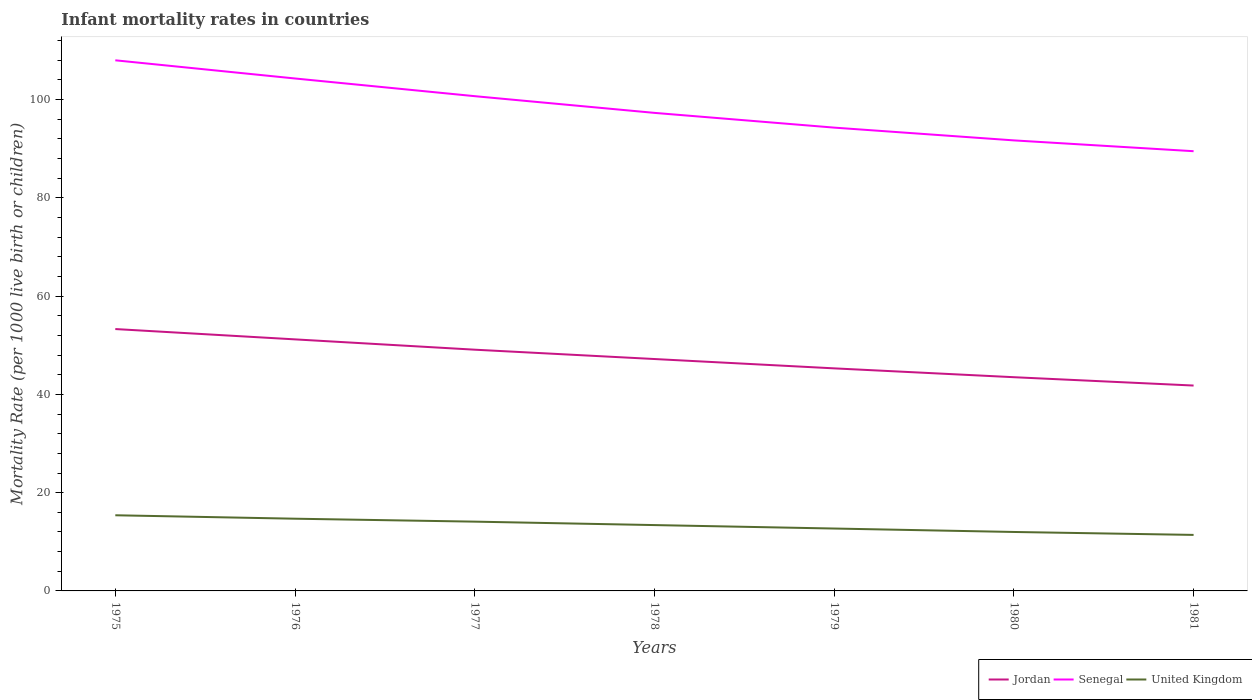Across all years, what is the maximum infant mortality rate in Jordan?
Make the answer very short. 41.8. In which year was the infant mortality rate in Senegal maximum?
Keep it short and to the point. 1981. What is the total infant mortality rate in Jordan in the graph?
Provide a short and direct response. 5.4. What is the difference between the highest and the second highest infant mortality rate in Senegal?
Your answer should be compact. 18.5. Is the infant mortality rate in Senegal strictly greater than the infant mortality rate in United Kingdom over the years?
Your answer should be compact. No. How many years are there in the graph?
Make the answer very short. 7. Are the values on the major ticks of Y-axis written in scientific E-notation?
Make the answer very short. No. Where does the legend appear in the graph?
Make the answer very short. Bottom right. What is the title of the graph?
Provide a short and direct response. Infant mortality rates in countries. What is the label or title of the X-axis?
Give a very brief answer. Years. What is the label or title of the Y-axis?
Make the answer very short. Mortality Rate (per 1000 live birth or children). What is the Mortality Rate (per 1000 live birth or children) in Jordan in 1975?
Offer a very short reply. 53.3. What is the Mortality Rate (per 1000 live birth or children) of Senegal in 1975?
Offer a very short reply. 108. What is the Mortality Rate (per 1000 live birth or children) in Jordan in 1976?
Your response must be concise. 51.2. What is the Mortality Rate (per 1000 live birth or children) of Senegal in 1976?
Make the answer very short. 104.3. What is the Mortality Rate (per 1000 live birth or children) of Jordan in 1977?
Your answer should be compact. 49.1. What is the Mortality Rate (per 1000 live birth or children) in Senegal in 1977?
Provide a short and direct response. 100.7. What is the Mortality Rate (per 1000 live birth or children) in United Kingdom in 1977?
Provide a succinct answer. 14.1. What is the Mortality Rate (per 1000 live birth or children) in Jordan in 1978?
Your response must be concise. 47.2. What is the Mortality Rate (per 1000 live birth or children) in Senegal in 1978?
Give a very brief answer. 97.3. What is the Mortality Rate (per 1000 live birth or children) in United Kingdom in 1978?
Your answer should be compact. 13.4. What is the Mortality Rate (per 1000 live birth or children) in Jordan in 1979?
Keep it short and to the point. 45.3. What is the Mortality Rate (per 1000 live birth or children) in Senegal in 1979?
Your response must be concise. 94.3. What is the Mortality Rate (per 1000 live birth or children) of United Kingdom in 1979?
Provide a short and direct response. 12.7. What is the Mortality Rate (per 1000 live birth or children) of Jordan in 1980?
Offer a terse response. 43.5. What is the Mortality Rate (per 1000 live birth or children) in Senegal in 1980?
Give a very brief answer. 91.7. What is the Mortality Rate (per 1000 live birth or children) in United Kingdom in 1980?
Your response must be concise. 12. What is the Mortality Rate (per 1000 live birth or children) in Jordan in 1981?
Your response must be concise. 41.8. What is the Mortality Rate (per 1000 live birth or children) of Senegal in 1981?
Provide a short and direct response. 89.5. Across all years, what is the maximum Mortality Rate (per 1000 live birth or children) of Jordan?
Give a very brief answer. 53.3. Across all years, what is the maximum Mortality Rate (per 1000 live birth or children) of Senegal?
Keep it short and to the point. 108. Across all years, what is the maximum Mortality Rate (per 1000 live birth or children) in United Kingdom?
Your response must be concise. 15.4. Across all years, what is the minimum Mortality Rate (per 1000 live birth or children) of Jordan?
Your answer should be compact. 41.8. Across all years, what is the minimum Mortality Rate (per 1000 live birth or children) of Senegal?
Offer a very short reply. 89.5. Across all years, what is the minimum Mortality Rate (per 1000 live birth or children) in United Kingdom?
Provide a succinct answer. 11.4. What is the total Mortality Rate (per 1000 live birth or children) in Jordan in the graph?
Ensure brevity in your answer.  331.4. What is the total Mortality Rate (per 1000 live birth or children) of Senegal in the graph?
Make the answer very short. 685.8. What is the total Mortality Rate (per 1000 live birth or children) of United Kingdom in the graph?
Give a very brief answer. 93.7. What is the difference between the Mortality Rate (per 1000 live birth or children) of Jordan in 1975 and that in 1976?
Give a very brief answer. 2.1. What is the difference between the Mortality Rate (per 1000 live birth or children) of United Kingdom in 1975 and that in 1978?
Keep it short and to the point. 2. What is the difference between the Mortality Rate (per 1000 live birth or children) of Jordan in 1975 and that in 1979?
Offer a terse response. 8. What is the difference between the Mortality Rate (per 1000 live birth or children) of Jordan in 1975 and that in 1980?
Your response must be concise. 9.8. What is the difference between the Mortality Rate (per 1000 live birth or children) in Jordan in 1975 and that in 1981?
Your answer should be compact. 11.5. What is the difference between the Mortality Rate (per 1000 live birth or children) in United Kingdom in 1975 and that in 1981?
Give a very brief answer. 4. What is the difference between the Mortality Rate (per 1000 live birth or children) of Jordan in 1976 and that in 1977?
Your response must be concise. 2.1. What is the difference between the Mortality Rate (per 1000 live birth or children) in Senegal in 1976 and that in 1977?
Keep it short and to the point. 3.6. What is the difference between the Mortality Rate (per 1000 live birth or children) of Jordan in 1976 and that in 1978?
Your answer should be compact. 4. What is the difference between the Mortality Rate (per 1000 live birth or children) in Senegal in 1976 and that in 1978?
Keep it short and to the point. 7. What is the difference between the Mortality Rate (per 1000 live birth or children) in United Kingdom in 1976 and that in 1978?
Provide a succinct answer. 1.3. What is the difference between the Mortality Rate (per 1000 live birth or children) in Jordan in 1976 and that in 1979?
Offer a terse response. 5.9. What is the difference between the Mortality Rate (per 1000 live birth or children) in Senegal in 1976 and that in 1979?
Your response must be concise. 10. What is the difference between the Mortality Rate (per 1000 live birth or children) of Jordan in 1976 and that in 1981?
Your answer should be compact. 9.4. What is the difference between the Mortality Rate (per 1000 live birth or children) of Senegal in 1976 and that in 1981?
Your response must be concise. 14.8. What is the difference between the Mortality Rate (per 1000 live birth or children) in Jordan in 1977 and that in 1979?
Your response must be concise. 3.8. What is the difference between the Mortality Rate (per 1000 live birth or children) in Senegal in 1977 and that in 1979?
Provide a short and direct response. 6.4. What is the difference between the Mortality Rate (per 1000 live birth or children) of United Kingdom in 1977 and that in 1979?
Your response must be concise. 1.4. What is the difference between the Mortality Rate (per 1000 live birth or children) of Senegal in 1977 and that in 1980?
Provide a short and direct response. 9. What is the difference between the Mortality Rate (per 1000 live birth or children) in Jordan in 1978 and that in 1979?
Keep it short and to the point. 1.9. What is the difference between the Mortality Rate (per 1000 live birth or children) in Senegal in 1978 and that in 1979?
Your response must be concise. 3. What is the difference between the Mortality Rate (per 1000 live birth or children) in Jordan in 1978 and that in 1980?
Provide a short and direct response. 3.7. What is the difference between the Mortality Rate (per 1000 live birth or children) of United Kingdom in 1978 and that in 1980?
Ensure brevity in your answer.  1.4. What is the difference between the Mortality Rate (per 1000 live birth or children) in Jordan in 1978 and that in 1981?
Give a very brief answer. 5.4. What is the difference between the Mortality Rate (per 1000 live birth or children) in Senegal in 1978 and that in 1981?
Offer a very short reply. 7.8. What is the difference between the Mortality Rate (per 1000 live birth or children) in United Kingdom in 1978 and that in 1981?
Your answer should be very brief. 2. What is the difference between the Mortality Rate (per 1000 live birth or children) of Senegal in 1979 and that in 1980?
Your response must be concise. 2.6. What is the difference between the Mortality Rate (per 1000 live birth or children) in United Kingdom in 1979 and that in 1981?
Ensure brevity in your answer.  1.3. What is the difference between the Mortality Rate (per 1000 live birth or children) of Senegal in 1980 and that in 1981?
Give a very brief answer. 2.2. What is the difference between the Mortality Rate (per 1000 live birth or children) of Jordan in 1975 and the Mortality Rate (per 1000 live birth or children) of Senegal in 1976?
Give a very brief answer. -51. What is the difference between the Mortality Rate (per 1000 live birth or children) of Jordan in 1975 and the Mortality Rate (per 1000 live birth or children) of United Kingdom in 1976?
Keep it short and to the point. 38.6. What is the difference between the Mortality Rate (per 1000 live birth or children) of Senegal in 1975 and the Mortality Rate (per 1000 live birth or children) of United Kingdom in 1976?
Your answer should be compact. 93.3. What is the difference between the Mortality Rate (per 1000 live birth or children) in Jordan in 1975 and the Mortality Rate (per 1000 live birth or children) in Senegal in 1977?
Offer a very short reply. -47.4. What is the difference between the Mortality Rate (per 1000 live birth or children) in Jordan in 1975 and the Mortality Rate (per 1000 live birth or children) in United Kingdom in 1977?
Offer a very short reply. 39.2. What is the difference between the Mortality Rate (per 1000 live birth or children) of Senegal in 1975 and the Mortality Rate (per 1000 live birth or children) of United Kingdom in 1977?
Offer a very short reply. 93.9. What is the difference between the Mortality Rate (per 1000 live birth or children) of Jordan in 1975 and the Mortality Rate (per 1000 live birth or children) of Senegal in 1978?
Your answer should be compact. -44. What is the difference between the Mortality Rate (per 1000 live birth or children) in Jordan in 1975 and the Mortality Rate (per 1000 live birth or children) in United Kingdom in 1978?
Keep it short and to the point. 39.9. What is the difference between the Mortality Rate (per 1000 live birth or children) in Senegal in 1975 and the Mortality Rate (per 1000 live birth or children) in United Kingdom in 1978?
Offer a terse response. 94.6. What is the difference between the Mortality Rate (per 1000 live birth or children) in Jordan in 1975 and the Mortality Rate (per 1000 live birth or children) in Senegal in 1979?
Provide a succinct answer. -41. What is the difference between the Mortality Rate (per 1000 live birth or children) in Jordan in 1975 and the Mortality Rate (per 1000 live birth or children) in United Kingdom in 1979?
Provide a short and direct response. 40.6. What is the difference between the Mortality Rate (per 1000 live birth or children) of Senegal in 1975 and the Mortality Rate (per 1000 live birth or children) of United Kingdom in 1979?
Give a very brief answer. 95.3. What is the difference between the Mortality Rate (per 1000 live birth or children) in Jordan in 1975 and the Mortality Rate (per 1000 live birth or children) in Senegal in 1980?
Offer a very short reply. -38.4. What is the difference between the Mortality Rate (per 1000 live birth or children) of Jordan in 1975 and the Mortality Rate (per 1000 live birth or children) of United Kingdom in 1980?
Offer a terse response. 41.3. What is the difference between the Mortality Rate (per 1000 live birth or children) in Senegal in 1975 and the Mortality Rate (per 1000 live birth or children) in United Kingdom in 1980?
Your answer should be compact. 96. What is the difference between the Mortality Rate (per 1000 live birth or children) of Jordan in 1975 and the Mortality Rate (per 1000 live birth or children) of Senegal in 1981?
Your answer should be compact. -36.2. What is the difference between the Mortality Rate (per 1000 live birth or children) in Jordan in 1975 and the Mortality Rate (per 1000 live birth or children) in United Kingdom in 1981?
Your response must be concise. 41.9. What is the difference between the Mortality Rate (per 1000 live birth or children) in Senegal in 1975 and the Mortality Rate (per 1000 live birth or children) in United Kingdom in 1981?
Keep it short and to the point. 96.6. What is the difference between the Mortality Rate (per 1000 live birth or children) of Jordan in 1976 and the Mortality Rate (per 1000 live birth or children) of Senegal in 1977?
Offer a very short reply. -49.5. What is the difference between the Mortality Rate (per 1000 live birth or children) in Jordan in 1976 and the Mortality Rate (per 1000 live birth or children) in United Kingdom in 1977?
Make the answer very short. 37.1. What is the difference between the Mortality Rate (per 1000 live birth or children) of Senegal in 1976 and the Mortality Rate (per 1000 live birth or children) of United Kingdom in 1977?
Ensure brevity in your answer.  90.2. What is the difference between the Mortality Rate (per 1000 live birth or children) of Jordan in 1976 and the Mortality Rate (per 1000 live birth or children) of Senegal in 1978?
Make the answer very short. -46.1. What is the difference between the Mortality Rate (per 1000 live birth or children) of Jordan in 1976 and the Mortality Rate (per 1000 live birth or children) of United Kingdom in 1978?
Ensure brevity in your answer.  37.8. What is the difference between the Mortality Rate (per 1000 live birth or children) in Senegal in 1976 and the Mortality Rate (per 1000 live birth or children) in United Kingdom in 1978?
Provide a succinct answer. 90.9. What is the difference between the Mortality Rate (per 1000 live birth or children) in Jordan in 1976 and the Mortality Rate (per 1000 live birth or children) in Senegal in 1979?
Provide a short and direct response. -43.1. What is the difference between the Mortality Rate (per 1000 live birth or children) of Jordan in 1976 and the Mortality Rate (per 1000 live birth or children) of United Kingdom in 1979?
Provide a short and direct response. 38.5. What is the difference between the Mortality Rate (per 1000 live birth or children) in Senegal in 1976 and the Mortality Rate (per 1000 live birth or children) in United Kingdom in 1979?
Your response must be concise. 91.6. What is the difference between the Mortality Rate (per 1000 live birth or children) of Jordan in 1976 and the Mortality Rate (per 1000 live birth or children) of Senegal in 1980?
Your response must be concise. -40.5. What is the difference between the Mortality Rate (per 1000 live birth or children) of Jordan in 1976 and the Mortality Rate (per 1000 live birth or children) of United Kingdom in 1980?
Give a very brief answer. 39.2. What is the difference between the Mortality Rate (per 1000 live birth or children) of Senegal in 1976 and the Mortality Rate (per 1000 live birth or children) of United Kingdom in 1980?
Give a very brief answer. 92.3. What is the difference between the Mortality Rate (per 1000 live birth or children) of Jordan in 1976 and the Mortality Rate (per 1000 live birth or children) of Senegal in 1981?
Give a very brief answer. -38.3. What is the difference between the Mortality Rate (per 1000 live birth or children) in Jordan in 1976 and the Mortality Rate (per 1000 live birth or children) in United Kingdom in 1981?
Your answer should be compact. 39.8. What is the difference between the Mortality Rate (per 1000 live birth or children) of Senegal in 1976 and the Mortality Rate (per 1000 live birth or children) of United Kingdom in 1981?
Make the answer very short. 92.9. What is the difference between the Mortality Rate (per 1000 live birth or children) of Jordan in 1977 and the Mortality Rate (per 1000 live birth or children) of Senegal in 1978?
Provide a succinct answer. -48.2. What is the difference between the Mortality Rate (per 1000 live birth or children) in Jordan in 1977 and the Mortality Rate (per 1000 live birth or children) in United Kingdom in 1978?
Ensure brevity in your answer.  35.7. What is the difference between the Mortality Rate (per 1000 live birth or children) of Senegal in 1977 and the Mortality Rate (per 1000 live birth or children) of United Kingdom in 1978?
Keep it short and to the point. 87.3. What is the difference between the Mortality Rate (per 1000 live birth or children) in Jordan in 1977 and the Mortality Rate (per 1000 live birth or children) in Senegal in 1979?
Your response must be concise. -45.2. What is the difference between the Mortality Rate (per 1000 live birth or children) in Jordan in 1977 and the Mortality Rate (per 1000 live birth or children) in United Kingdom in 1979?
Keep it short and to the point. 36.4. What is the difference between the Mortality Rate (per 1000 live birth or children) of Jordan in 1977 and the Mortality Rate (per 1000 live birth or children) of Senegal in 1980?
Provide a succinct answer. -42.6. What is the difference between the Mortality Rate (per 1000 live birth or children) in Jordan in 1977 and the Mortality Rate (per 1000 live birth or children) in United Kingdom in 1980?
Provide a succinct answer. 37.1. What is the difference between the Mortality Rate (per 1000 live birth or children) in Senegal in 1977 and the Mortality Rate (per 1000 live birth or children) in United Kingdom in 1980?
Your answer should be compact. 88.7. What is the difference between the Mortality Rate (per 1000 live birth or children) of Jordan in 1977 and the Mortality Rate (per 1000 live birth or children) of Senegal in 1981?
Make the answer very short. -40.4. What is the difference between the Mortality Rate (per 1000 live birth or children) of Jordan in 1977 and the Mortality Rate (per 1000 live birth or children) of United Kingdom in 1981?
Your answer should be compact. 37.7. What is the difference between the Mortality Rate (per 1000 live birth or children) of Senegal in 1977 and the Mortality Rate (per 1000 live birth or children) of United Kingdom in 1981?
Keep it short and to the point. 89.3. What is the difference between the Mortality Rate (per 1000 live birth or children) of Jordan in 1978 and the Mortality Rate (per 1000 live birth or children) of Senegal in 1979?
Give a very brief answer. -47.1. What is the difference between the Mortality Rate (per 1000 live birth or children) of Jordan in 1978 and the Mortality Rate (per 1000 live birth or children) of United Kingdom in 1979?
Ensure brevity in your answer.  34.5. What is the difference between the Mortality Rate (per 1000 live birth or children) in Senegal in 1978 and the Mortality Rate (per 1000 live birth or children) in United Kingdom in 1979?
Your response must be concise. 84.6. What is the difference between the Mortality Rate (per 1000 live birth or children) in Jordan in 1978 and the Mortality Rate (per 1000 live birth or children) in Senegal in 1980?
Provide a succinct answer. -44.5. What is the difference between the Mortality Rate (per 1000 live birth or children) in Jordan in 1978 and the Mortality Rate (per 1000 live birth or children) in United Kingdom in 1980?
Your answer should be very brief. 35.2. What is the difference between the Mortality Rate (per 1000 live birth or children) of Senegal in 1978 and the Mortality Rate (per 1000 live birth or children) of United Kingdom in 1980?
Give a very brief answer. 85.3. What is the difference between the Mortality Rate (per 1000 live birth or children) in Jordan in 1978 and the Mortality Rate (per 1000 live birth or children) in Senegal in 1981?
Offer a terse response. -42.3. What is the difference between the Mortality Rate (per 1000 live birth or children) in Jordan in 1978 and the Mortality Rate (per 1000 live birth or children) in United Kingdom in 1981?
Give a very brief answer. 35.8. What is the difference between the Mortality Rate (per 1000 live birth or children) in Senegal in 1978 and the Mortality Rate (per 1000 live birth or children) in United Kingdom in 1981?
Make the answer very short. 85.9. What is the difference between the Mortality Rate (per 1000 live birth or children) in Jordan in 1979 and the Mortality Rate (per 1000 live birth or children) in Senegal in 1980?
Give a very brief answer. -46.4. What is the difference between the Mortality Rate (per 1000 live birth or children) of Jordan in 1979 and the Mortality Rate (per 1000 live birth or children) of United Kingdom in 1980?
Offer a very short reply. 33.3. What is the difference between the Mortality Rate (per 1000 live birth or children) in Senegal in 1979 and the Mortality Rate (per 1000 live birth or children) in United Kingdom in 1980?
Ensure brevity in your answer.  82.3. What is the difference between the Mortality Rate (per 1000 live birth or children) of Jordan in 1979 and the Mortality Rate (per 1000 live birth or children) of Senegal in 1981?
Offer a terse response. -44.2. What is the difference between the Mortality Rate (per 1000 live birth or children) in Jordan in 1979 and the Mortality Rate (per 1000 live birth or children) in United Kingdom in 1981?
Offer a terse response. 33.9. What is the difference between the Mortality Rate (per 1000 live birth or children) in Senegal in 1979 and the Mortality Rate (per 1000 live birth or children) in United Kingdom in 1981?
Provide a short and direct response. 82.9. What is the difference between the Mortality Rate (per 1000 live birth or children) in Jordan in 1980 and the Mortality Rate (per 1000 live birth or children) in Senegal in 1981?
Your answer should be very brief. -46. What is the difference between the Mortality Rate (per 1000 live birth or children) of Jordan in 1980 and the Mortality Rate (per 1000 live birth or children) of United Kingdom in 1981?
Your answer should be compact. 32.1. What is the difference between the Mortality Rate (per 1000 live birth or children) in Senegal in 1980 and the Mortality Rate (per 1000 live birth or children) in United Kingdom in 1981?
Your response must be concise. 80.3. What is the average Mortality Rate (per 1000 live birth or children) of Jordan per year?
Your answer should be compact. 47.34. What is the average Mortality Rate (per 1000 live birth or children) in Senegal per year?
Keep it short and to the point. 97.97. What is the average Mortality Rate (per 1000 live birth or children) of United Kingdom per year?
Offer a very short reply. 13.39. In the year 1975, what is the difference between the Mortality Rate (per 1000 live birth or children) in Jordan and Mortality Rate (per 1000 live birth or children) in Senegal?
Give a very brief answer. -54.7. In the year 1975, what is the difference between the Mortality Rate (per 1000 live birth or children) in Jordan and Mortality Rate (per 1000 live birth or children) in United Kingdom?
Provide a short and direct response. 37.9. In the year 1975, what is the difference between the Mortality Rate (per 1000 live birth or children) of Senegal and Mortality Rate (per 1000 live birth or children) of United Kingdom?
Offer a terse response. 92.6. In the year 1976, what is the difference between the Mortality Rate (per 1000 live birth or children) of Jordan and Mortality Rate (per 1000 live birth or children) of Senegal?
Your answer should be compact. -53.1. In the year 1976, what is the difference between the Mortality Rate (per 1000 live birth or children) of Jordan and Mortality Rate (per 1000 live birth or children) of United Kingdom?
Keep it short and to the point. 36.5. In the year 1976, what is the difference between the Mortality Rate (per 1000 live birth or children) in Senegal and Mortality Rate (per 1000 live birth or children) in United Kingdom?
Your answer should be very brief. 89.6. In the year 1977, what is the difference between the Mortality Rate (per 1000 live birth or children) of Jordan and Mortality Rate (per 1000 live birth or children) of Senegal?
Your answer should be very brief. -51.6. In the year 1977, what is the difference between the Mortality Rate (per 1000 live birth or children) of Jordan and Mortality Rate (per 1000 live birth or children) of United Kingdom?
Your answer should be compact. 35. In the year 1977, what is the difference between the Mortality Rate (per 1000 live birth or children) in Senegal and Mortality Rate (per 1000 live birth or children) in United Kingdom?
Keep it short and to the point. 86.6. In the year 1978, what is the difference between the Mortality Rate (per 1000 live birth or children) in Jordan and Mortality Rate (per 1000 live birth or children) in Senegal?
Ensure brevity in your answer.  -50.1. In the year 1978, what is the difference between the Mortality Rate (per 1000 live birth or children) in Jordan and Mortality Rate (per 1000 live birth or children) in United Kingdom?
Offer a terse response. 33.8. In the year 1978, what is the difference between the Mortality Rate (per 1000 live birth or children) of Senegal and Mortality Rate (per 1000 live birth or children) of United Kingdom?
Keep it short and to the point. 83.9. In the year 1979, what is the difference between the Mortality Rate (per 1000 live birth or children) in Jordan and Mortality Rate (per 1000 live birth or children) in Senegal?
Ensure brevity in your answer.  -49. In the year 1979, what is the difference between the Mortality Rate (per 1000 live birth or children) in Jordan and Mortality Rate (per 1000 live birth or children) in United Kingdom?
Give a very brief answer. 32.6. In the year 1979, what is the difference between the Mortality Rate (per 1000 live birth or children) in Senegal and Mortality Rate (per 1000 live birth or children) in United Kingdom?
Offer a terse response. 81.6. In the year 1980, what is the difference between the Mortality Rate (per 1000 live birth or children) in Jordan and Mortality Rate (per 1000 live birth or children) in Senegal?
Your answer should be very brief. -48.2. In the year 1980, what is the difference between the Mortality Rate (per 1000 live birth or children) of Jordan and Mortality Rate (per 1000 live birth or children) of United Kingdom?
Your answer should be compact. 31.5. In the year 1980, what is the difference between the Mortality Rate (per 1000 live birth or children) of Senegal and Mortality Rate (per 1000 live birth or children) of United Kingdom?
Your answer should be very brief. 79.7. In the year 1981, what is the difference between the Mortality Rate (per 1000 live birth or children) of Jordan and Mortality Rate (per 1000 live birth or children) of Senegal?
Provide a succinct answer. -47.7. In the year 1981, what is the difference between the Mortality Rate (per 1000 live birth or children) of Jordan and Mortality Rate (per 1000 live birth or children) of United Kingdom?
Make the answer very short. 30.4. In the year 1981, what is the difference between the Mortality Rate (per 1000 live birth or children) in Senegal and Mortality Rate (per 1000 live birth or children) in United Kingdom?
Give a very brief answer. 78.1. What is the ratio of the Mortality Rate (per 1000 live birth or children) of Jordan in 1975 to that in 1976?
Ensure brevity in your answer.  1.04. What is the ratio of the Mortality Rate (per 1000 live birth or children) in Senegal in 1975 to that in 1976?
Offer a terse response. 1.04. What is the ratio of the Mortality Rate (per 1000 live birth or children) of United Kingdom in 1975 to that in 1976?
Provide a succinct answer. 1.05. What is the ratio of the Mortality Rate (per 1000 live birth or children) in Jordan in 1975 to that in 1977?
Offer a terse response. 1.09. What is the ratio of the Mortality Rate (per 1000 live birth or children) in Senegal in 1975 to that in 1977?
Your answer should be compact. 1.07. What is the ratio of the Mortality Rate (per 1000 live birth or children) in United Kingdom in 1975 to that in 1977?
Provide a succinct answer. 1.09. What is the ratio of the Mortality Rate (per 1000 live birth or children) of Jordan in 1975 to that in 1978?
Your answer should be compact. 1.13. What is the ratio of the Mortality Rate (per 1000 live birth or children) in Senegal in 1975 to that in 1978?
Offer a very short reply. 1.11. What is the ratio of the Mortality Rate (per 1000 live birth or children) in United Kingdom in 1975 to that in 1978?
Ensure brevity in your answer.  1.15. What is the ratio of the Mortality Rate (per 1000 live birth or children) of Jordan in 1975 to that in 1979?
Make the answer very short. 1.18. What is the ratio of the Mortality Rate (per 1000 live birth or children) in Senegal in 1975 to that in 1979?
Provide a short and direct response. 1.15. What is the ratio of the Mortality Rate (per 1000 live birth or children) of United Kingdom in 1975 to that in 1979?
Your answer should be very brief. 1.21. What is the ratio of the Mortality Rate (per 1000 live birth or children) of Jordan in 1975 to that in 1980?
Your answer should be very brief. 1.23. What is the ratio of the Mortality Rate (per 1000 live birth or children) of Senegal in 1975 to that in 1980?
Your answer should be very brief. 1.18. What is the ratio of the Mortality Rate (per 1000 live birth or children) of United Kingdom in 1975 to that in 1980?
Your response must be concise. 1.28. What is the ratio of the Mortality Rate (per 1000 live birth or children) in Jordan in 1975 to that in 1981?
Make the answer very short. 1.28. What is the ratio of the Mortality Rate (per 1000 live birth or children) in Senegal in 1975 to that in 1981?
Offer a very short reply. 1.21. What is the ratio of the Mortality Rate (per 1000 live birth or children) of United Kingdom in 1975 to that in 1981?
Your response must be concise. 1.35. What is the ratio of the Mortality Rate (per 1000 live birth or children) in Jordan in 1976 to that in 1977?
Your response must be concise. 1.04. What is the ratio of the Mortality Rate (per 1000 live birth or children) of Senegal in 1976 to that in 1977?
Give a very brief answer. 1.04. What is the ratio of the Mortality Rate (per 1000 live birth or children) of United Kingdom in 1976 to that in 1977?
Give a very brief answer. 1.04. What is the ratio of the Mortality Rate (per 1000 live birth or children) of Jordan in 1976 to that in 1978?
Offer a very short reply. 1.08. What is the ratio of the Mortality Rate (per 1000 live birth or children) in Senegal in 1976 to that in 1978?
Provide a succinct answer. 1.07. What is the ratio of the Mortality Rate (per 1000 live birth or children) of United Kingdom in 1976 to that in 1978?
Your response must be concise. 1.1. What is the ratio of the Mortality Rate (per 1000 live birth or children) in Jordan in 1976 to that in 1979?
Your answer should be compact. 1.13. What is the ratio of the Mortality Rate (per 1000 live birth or children) in Senegal in 1976 to that in 1979?
Give a very brief answer. 1.11. What is the ratio of the Mortality Rate (per 1000 live birth or children) in United Kingdom in 1976 to that in 1979?
Provide a succinct answer. 1.16. What is the ratio of the Mortality Rate (per 1000 live birth or children) in Jordan in 1976 to that in 1980?
Your answer should be compact. 1.18. What is the ratio of the Mortality Rate (per 1000 live birth or children) of Senegal in 1976 to that in 1980?
Keep it short and to the point. 1.14. What is the ratio of the Mortality Rate (per 1000 live birth or children) of United Kingdom in 1976 to that in 1980?
Ensure brevity in your answer.  1.23. What is the ratio of the Mortality Rate (per 1000 live birth or children) in Jordan in 1976 to that in 1981?
Make the answer very short. 1.22. What is the ratio of the Mortality Rate (per 1000 live birth or children) of Senegal in 1976 to that in 1981?
Your response must be concise. 1.17. What is the ratio of the Mortality Rate (per 1000 live birth or children) in United Kingdom in 1976 to that in 1981?
Make the answer very short. 1.29. What is the ratio of the Mortality Rate (per 1000 live birth or children) of Jordan in 1977 to that in 1978?
Make the answer very short. 1.04. What is the ratio of the Mortality Rate (per 1000 live birth or children) of Senegal in 1977 to that in 1978?
Provide a short and direct response. 1.03. What is the ratio of the Mortality Rate (per 1000 live birth or children) in United Kingdom in 1977 to that in 1978?
Offer a terse response. 1.05. What is the ratio of the Mortality Rate (per 1000 live birth or children) in Jordan in 1977 to that in 1979?
Your answer should be compact. 1.08. What is the ratio of the Mortality Rate (per 1000 live birth or children) in Senegal in 1977 to that in 1979?
Offer a very short reply. 1.07. What is the ratio of the Mortality Rate (per 1000 live birth or children) in United Kingdom in 1977 to that in 1979?
Keep it short and to the point. 1.11. What is the ratio of the Mortality Rate (per 1000 live birth or children) in Jordan in 1977 to that in 1980?
Your answer should be compact. 1.13. What is the ratio of the Mortality Rate (per 1000 live birth or children) in Senegal in 1977 to that in 1980?
Give a very brief answer. 1.1. What is the ratio of the Mortality Rate (per 1000 live birth or children) of United Kingdom in 1977 to that in 1980?
Give a very brief answer. 1.18. What is the ratio of the Mortality Rate (per 1000 live birth or children) of Jordan in 1977 to that in 1981?
Offer a terse response. 1.17. What is the ratio of the Mortality Rate (per 1000 live birth or children) in Senegal in 1977 to that in 1981?
Offer a terse response. 1.13. What is the ratio of the Mortality Rate (per 1000 live birth or children) of United Kingdom in 1977 to that in 1981?
Your answer should be very brief. 1.24. What is the ratio of the Mortality Rate (per 1000 live birth or children) of Jordan in 1978 to that in 1979?
Make the answer very short. 1.04. What is the ratio of the Mortality Rate (per 1000 live birth or children) in Senegal in 1978 to that in 1979?
Ensure brevity in your answer.  1.03. What is the ratio of the Mortality Rate (per 1000 live birth or children) in United Kingdom in 1978 to that in 1979?
Your response must be concise. 1.06. What is the ratio of the Mortality Rate (per 1000 live birth or children) of Jordan in 1978 to that in 1980?
Keep it short and to the point. 1.09. What is the ratio of the Mortality Rate (per 1000 live birth or children) in Senegal in 1978 to that in 1980?
Make the answer very short. 1.06. What is the ratio of the Mortality Rate (per 1000 live birth or children) in United Kingdom in 1978 to that in 1980?
Keep it short and to the point. 1.12. What is the ratio of the Mortality Rate (per 1000 live birth or children) in Jordan in 1978 to that in 1981?
Provide a short and direct response. 1.13. What is the ratio of the Mortality Rate (per 1000 live birth or children) of Senegal in 1978 to that in 1981?
Offer a terse response. 1.09. What is the ratio of the Mortality Rate (per 1000 live birth or children) in United Kingdom in 1978 to that in 1981?
Your answer should be compact. 1.18. What is the ratio of the Mortality Rate (per 1000 live birth or children) in Jordan in 1979 to that in 1980?
Offer a terse response. 1.04. What is the ratio of the Mortality Rate (per 1000 live birth or children) of Senegal in 1979 to that in 1980?
Keep it short and to the point. 1.03. What is the ratio of the Mortality Rate (per 1000 live birth or children) of United Kingdom in 1979 to that in 1980?
Offer a very short reply. 1.06. What is the ratio of the Mortality Rate (per 1000 live birth or children) in Jordan in 1979 to that in 1981?
Offer a very short reply. 1.08. What is the ratio of the Mortality Rate (per 1000 live birth or children) in Senegal in 1979 to that in 1981?
Offer a terse response. 1.05. What is the ratio of the Mortality Rate (per 1000 live birth or children) in United Kingdom in 1979 to that in 1981?
Your answer should be compact. 1.11. What is the ratio of the Mortality Rate (per 1000 live birth or children) in Jordan in 1980 to that in 1981?
Provide a short and direct response. 1.04. What is the ratio of the Mortality Rate (per 1000 live birth or children) of Senegal in 1980 to that in 1981?
Offer a very short reply. 1.02. What is the ratio of the Mortality Rate (per 1000 live birth or children) in United Kingdom in 1980 to that in 1981?
Offer a very short reply. 1.05. 